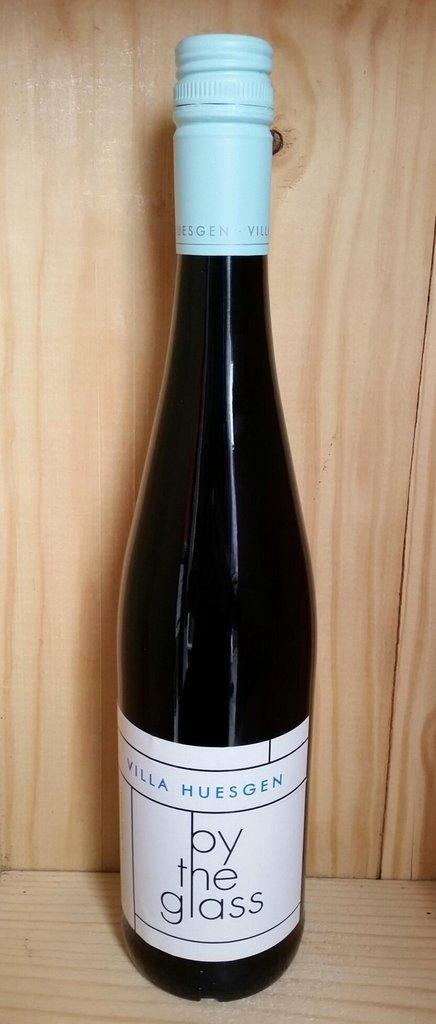Please provide a concise description of this image. In this image we can see a bottle and there is some text on it and the bottle placed on a surface which looks like a table. 